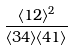<formula> <loc_0><loc_0><loc_500><loc_500>\frac { \langle 1 2 \rangle ^ { 2 } } { \langle 3 4 \rangle \langle 4 1 \rangle }</formula> 